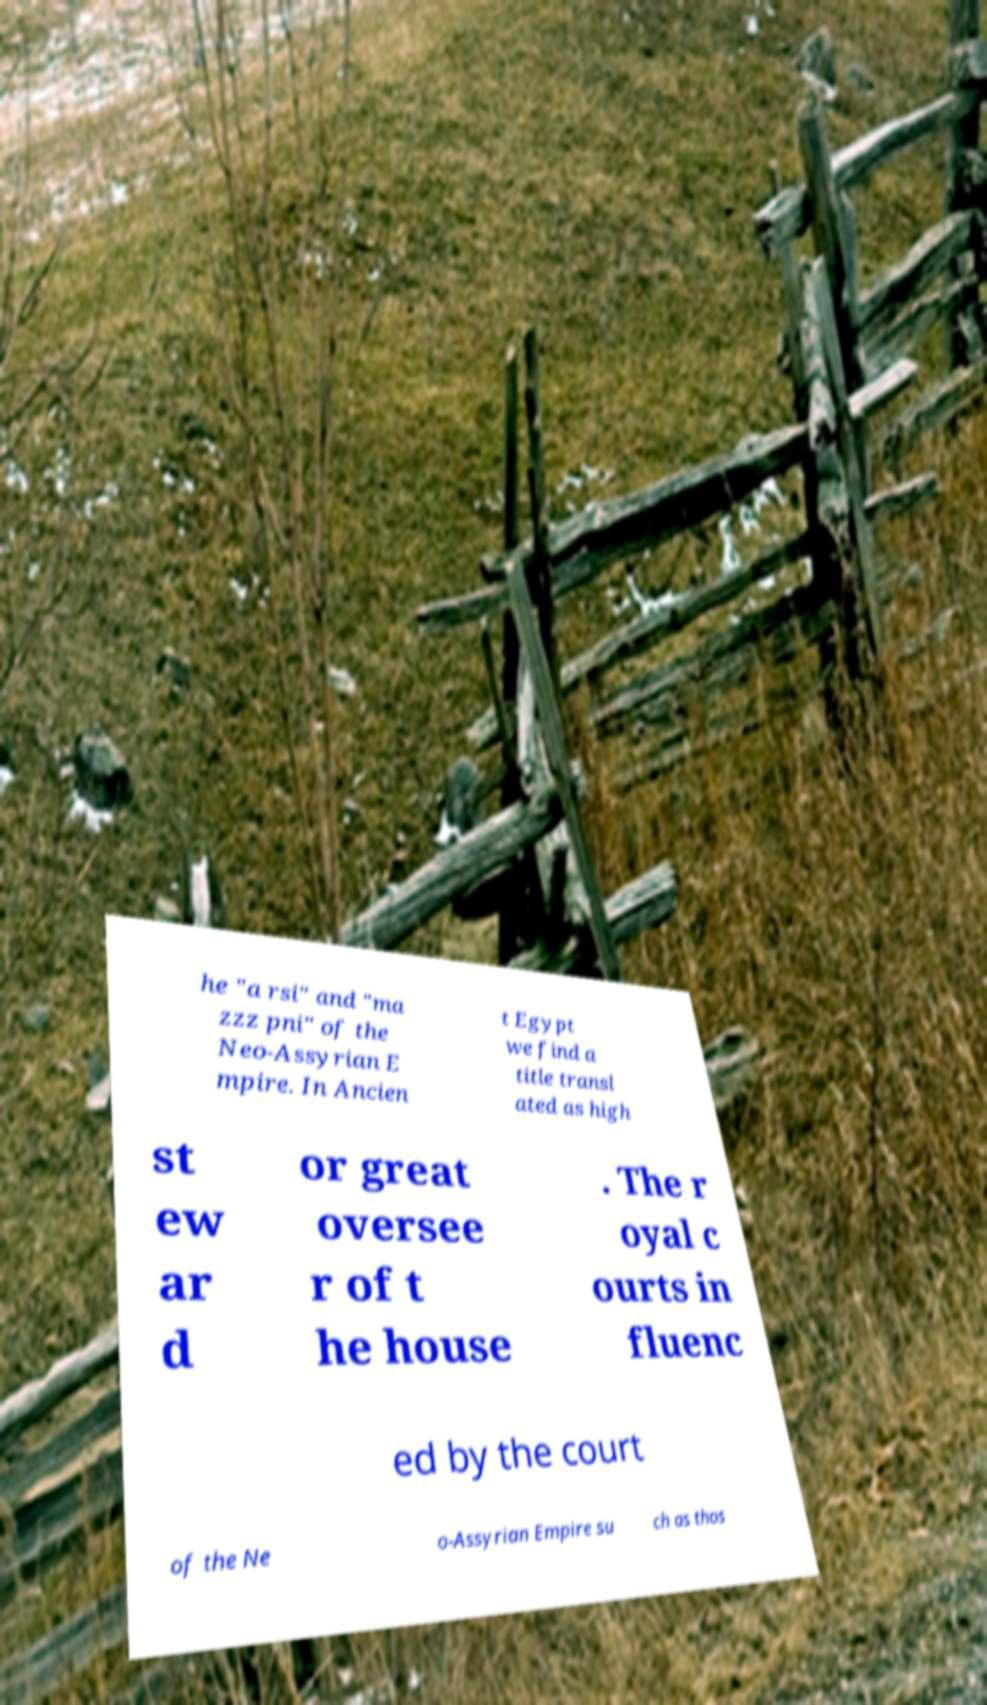Can you read and provide the text displayed in the image?This photo seems to have some interesting text. Can you extract and type it out for me? he "a rsi" and "ma zzz pni" of the Neo-Assyrian E mpire. In Ancien t Egypt we find a title transl ated as high st ew ar d or great oversee r of t he house . The r oyal c ourts in fluenc ed by the court of the Ne o-Assyrian Empire su ch as thos 